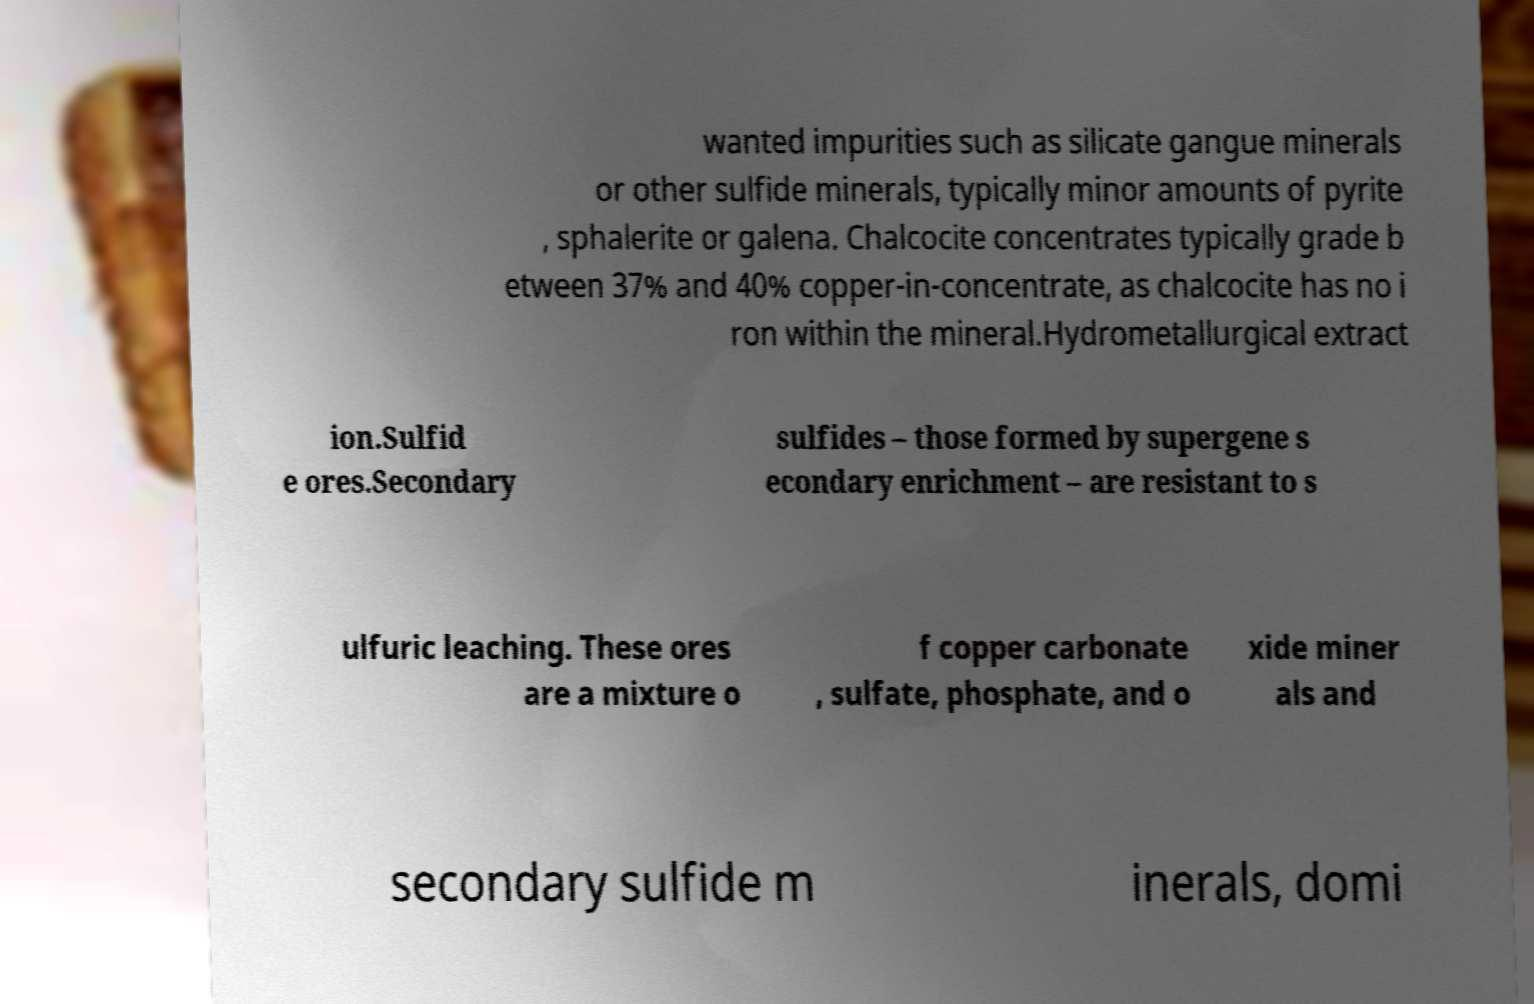For documentation purposes, I need the text within this image transcribed. Could you provide that? wanted impurities such as silicate gangue minerals or other sulfide minerals, typically minor amounts of pyrite , sphalerite or galena. Chalcocite concentrates typically grade b etween 37% and 40% copper-in-concentrate, as chalcocite has no i ron within the mineral.Hydrometallurgical extract ion.Sulfid e ores.Secondary sulfides – those formed by supergene s econdary enrichment – are resistant to s ulfuric leaching. These ores are a mixture o f copper carbonate , sulfate, phosphate, and o xide miner als and secondary sulfide m inerals, domi 